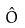Convert formula to latex. <formula><loc_0><loc_0><loc_500><loc_500>\hat { O }</formula> 